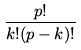<formula> <loc_0><loc_0><loc_500><loc_500>\frac { p ! } { k ! ( p - k ) ! }</formula> 